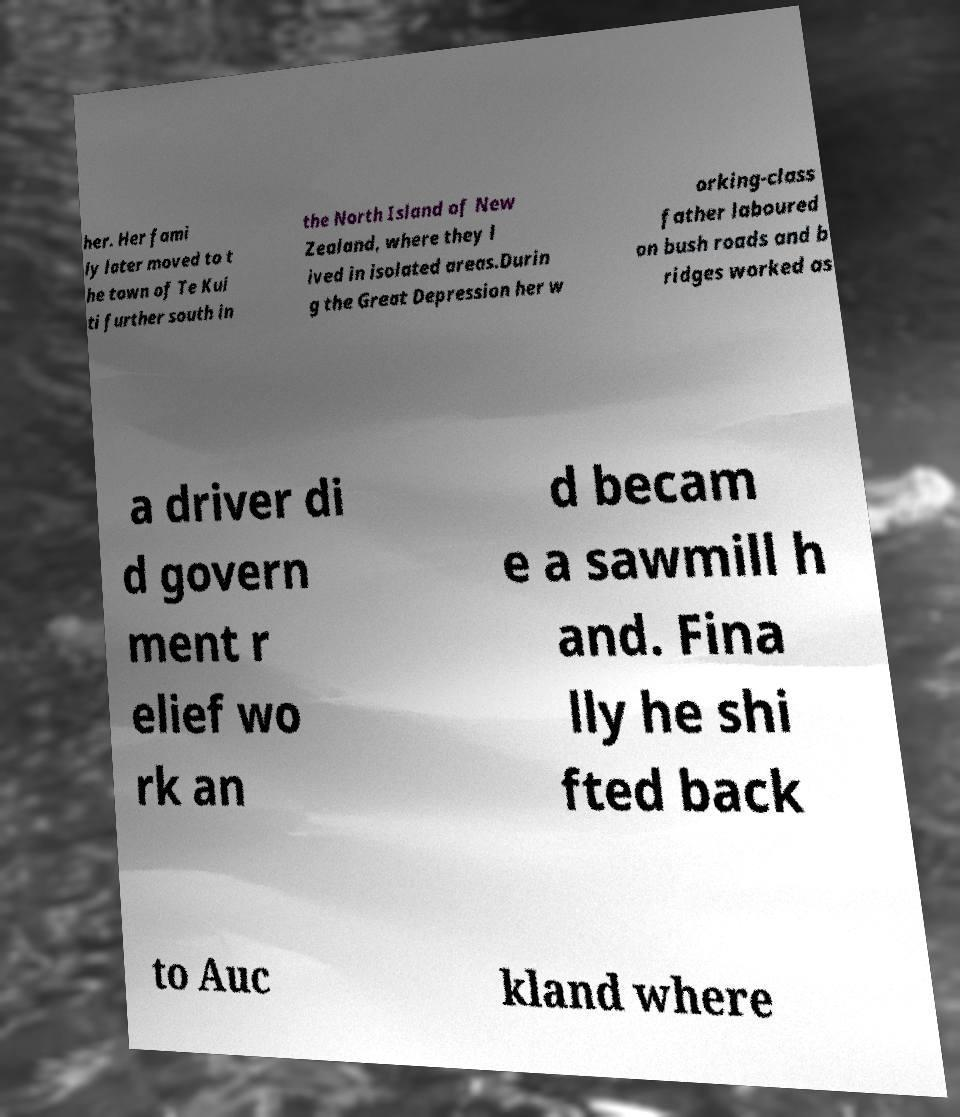Can you accurately transcribe the text from the provided image for me? her. Her fami ly later moved to t he town of Te Kui ti further south in the North Island of New Zealand, where they l ived in isolated areas.Durin g the Great Depression her w orking-class father laboured on bush roads and b ridges worked as a driver di d govern ment r elief wo rk an d becam e a sawmill h and. Fina lly he shi fted back to Auc kland where 